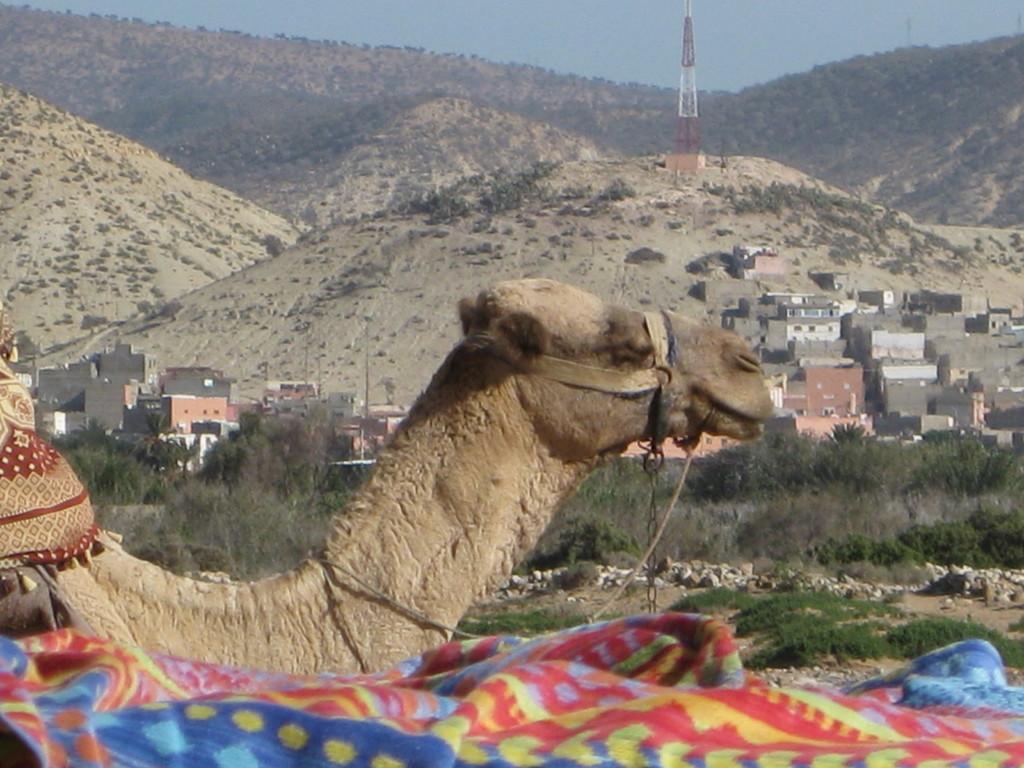Describe this image in one or two sentences. In this picture there is a camel in the center of the image and there are houses and trees in the background area of the image and there are mountains and a tower at the top side of the image. 